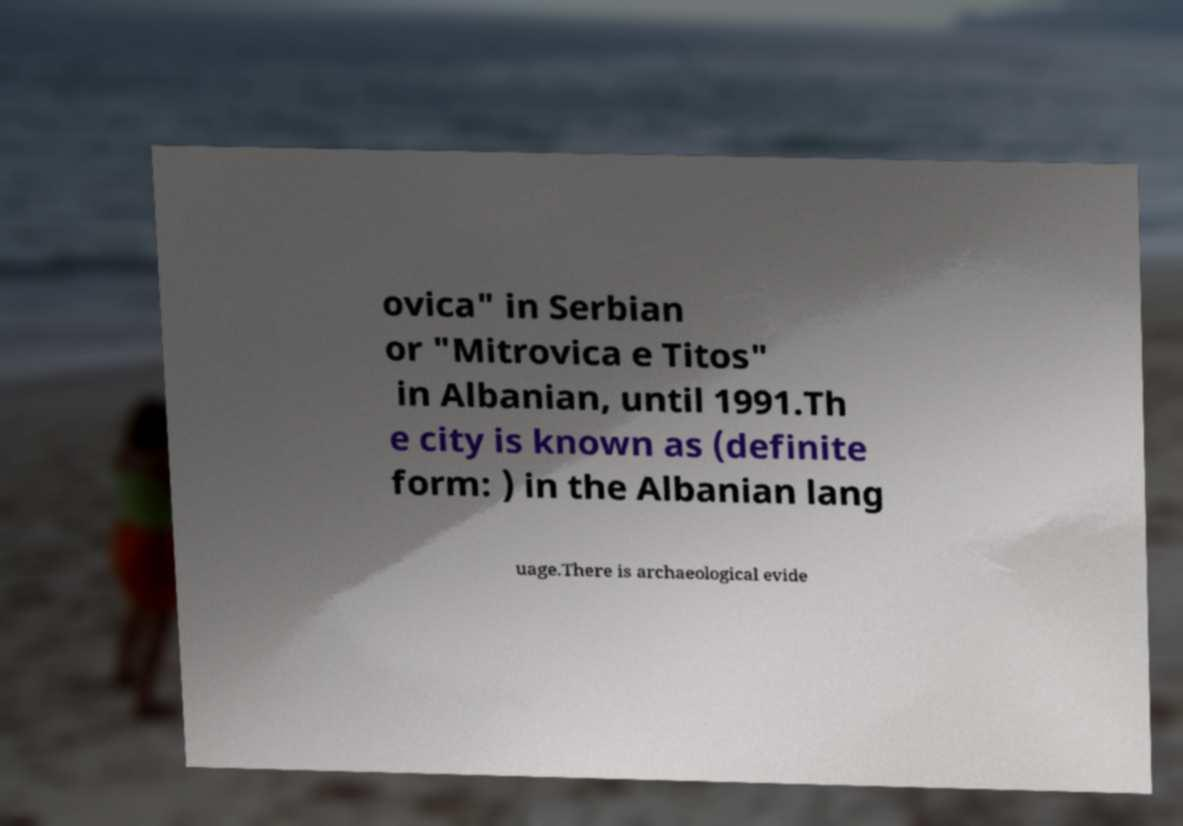Please read and relay the text visible in this image. What does it say? ovica" in Serbian or "Mitrovica e Titos" in Albanian, until 1991.Th e city is known as (definite form: ) in the Albanian lang uage.There is archaeological evide 